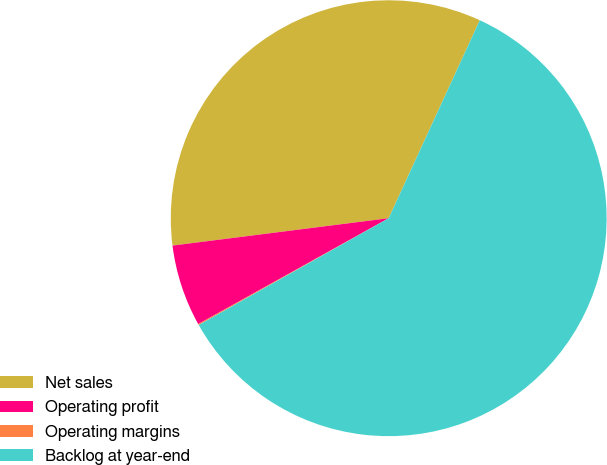Convert chart to OTSL. <chart><loc_0><loc_0><loc_500><loc_500><pie_chart><fcel>Net sales<fcel>Operating profit<fcel>Operating margins<fcel>Backlog at year-end<nl><fcel>33.87%<fcel>6.07%<fcel>0.08%<fcel>59.98%<nl></chart> 